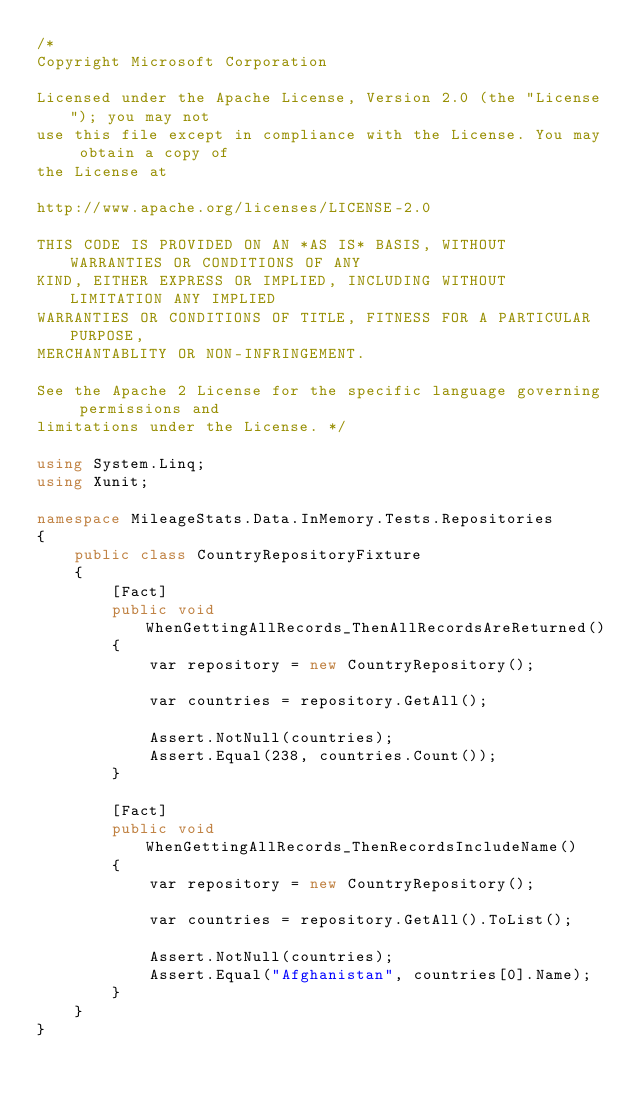Convert code to text. <code><loc_0><loc_0><loc_500><loc_500><_C#_>/*  
Copyright Microsoft Corporation

Licensed under the Apache License, Version 2.0 (the "License"); you may not
use this file except in compliance with the License. You may obtain a copy of
the License at 

http://www.apache.org/licenses/LICENSE-2.0 

THIS CODE IS PROVIDED ON AN *AS IS* BASIS, WITHOUT WARRANTIES OR CONDITIONS OF ANY
KIND, EITHER EXPRESS OR IMPLIED, INCLUDING WITHOUT LIMITATION ANY IMPLIED 
WARRANTIES OR CONDITIONS OF TITLE, FITNESS FOR A PARTICULAR PURPOSE, 
MERCHANTABLITY OR NON-INFRINGEMENT. 

See the Apache 2 License for the specific language governing permissions and
limitations under the License. */

using System.Linq;
using Xunit;

namespace MileageStats.Data.InMemory.Tests.Repositories
{
    public class CountryRepositoryFixture
    {
        [Fact]
        public void WhenGettingAllRecords_ThenAllRecordsAreReturned()
        {
            var repository = new CountryRepository();

            var countries = repository.GetAll();

            Assert.NotNull(countries);
            Assert.Equal(238, countries.Count());
        }

        [Fact]
        public void WhenGettingAllRecords_ThenRecordsIncludeName()
        {
            var repository = new CountryRepository();

            var countries = repository.GetAll().ToList();

            Assert.NotNull(countries);
            Assert.Equal("Afghanistan", countries[0].Name);
        }
    }
}</code> 